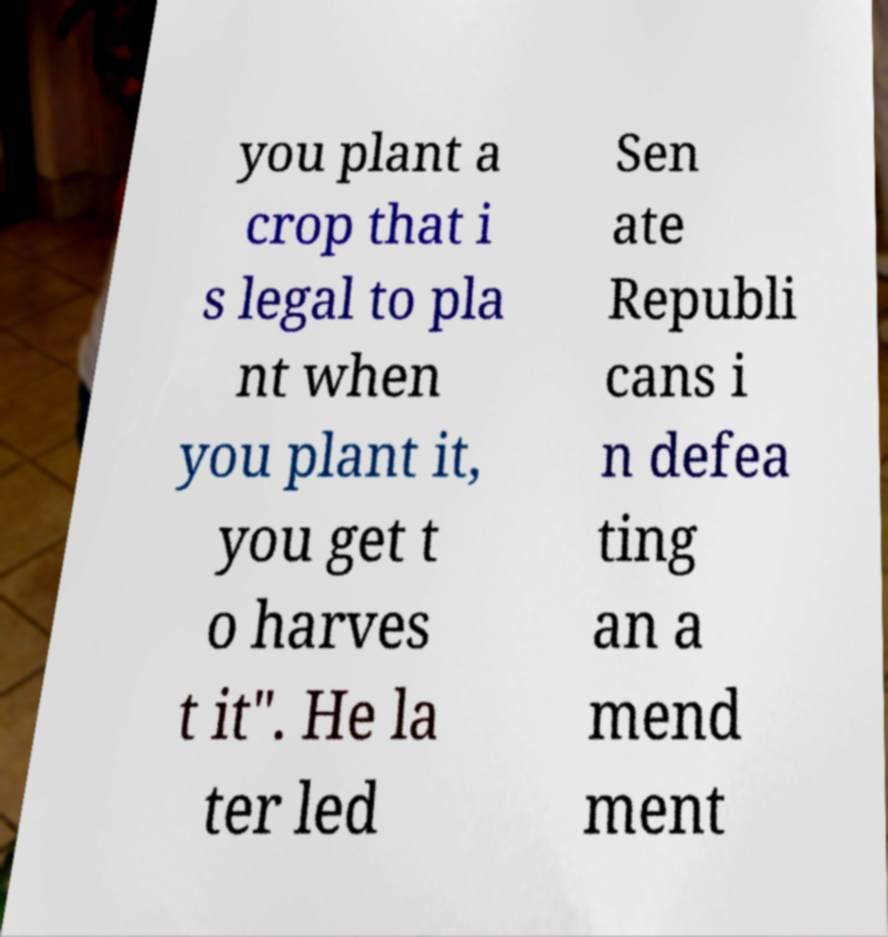I need the written content from this picture converted into text. Can you do that? you plant a crop that i s legal to pla nt when you plant it, you get t o harves t it". He la ter led Sen ate Republi cans i n defea ting an a mend ment 